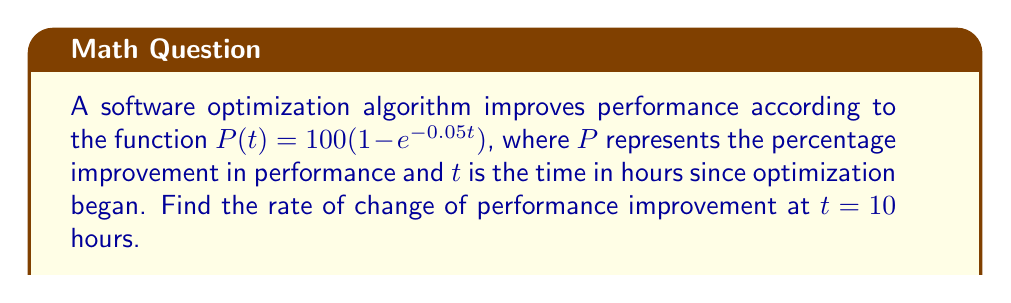Can you answer this question? To find the rate of change of performance improvement at $t = 10$ hours, we need to calculate the derivative of $P(t)$ and evaluate it at $t = 10$.

Step 1: Calculate the derivative of $P(t)$
$$\frac{d}{dt}P(t) = \frac{d}{dt}[100(1 - e^{-0.05t})]$$
$$= 100 \cdot \frac{d}{dt}[1 - e^{-0.05t}]$$
$$= 100 \cdot (-1) \cdot \frac{d}{dt}[e^{-0.05t}]$$
$$= -100 \cdot e^{-0.05t} \cdot (-0.05)$$
$$= 5e^{-0.05t}$$

Step 2: Evaluate the derivative at $t = 10$
$$\frac{d}{dt}P(10) = 5e^{-0.05(10)}$$
$$= 5e^{-0.5}$$
$$\approx 3.0327$$

Therefore, the rate of change of performance improvement at $t = 10$ hours is approximately 3.0327% per hour.
Answer: $5e^{-0.5}$ % per hour 